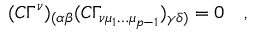<formula> <loc_0><loc_0><loc_500><loc_500>( C \Gamma ^ { \nu } ) _ { ( \alpha \beta } ( C \Gamma _ { \nu \mu _ { 1 } \dots \mu _ { p - 1 } } ) _ { \gamma \delta ) } = 0 \quad ,</formula> 